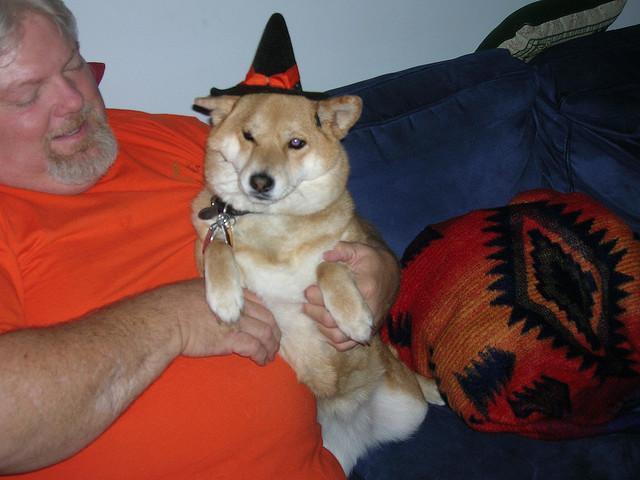Evaluate: Does the caption "The person is in front of the couch." match the image?
Answer yes or no. No. 